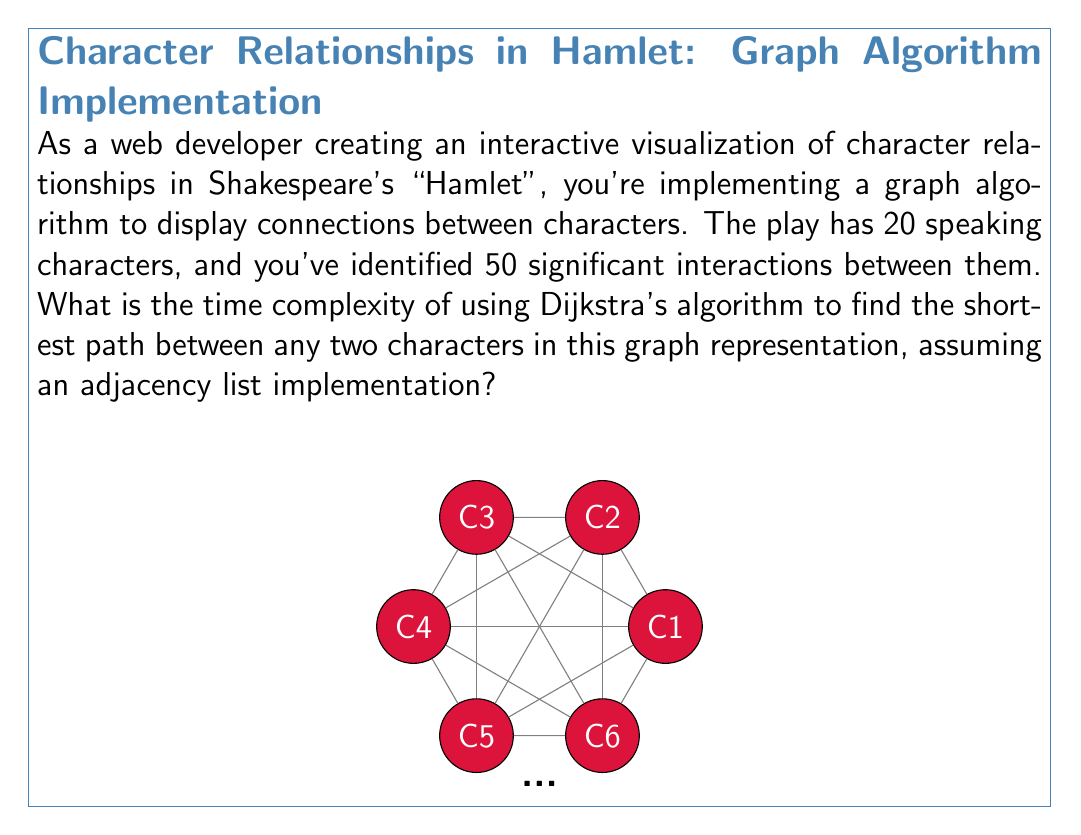Can you solve this math problem? Let's break this down step-by-step:

1) In graph theory, we represent the number of vertices as $V$ and the number of edges as $E$. In this case:
   $V = 20$ (characters)
   $E = 50$ (interactions)

2) Dijkstra's algorithm, when implemented with an adjacency list and a binary heap for the priority queue, has a time complexity of:

   $$O((V + E) \log V)$$

3) This is because:
   - Each vertex is inserted into and extracted from the priority queue once: $O(V \log V)$
   - Each edge is examined once, and may cause an update to the priority queue: $O(E \log V)$

4) Substituting our values:

   $$O((20 + 50) \log 20)$$

5) Simplifying:

   $$O(70 \log 20)$$

6) The $\log 20$ is a constant, so we can simplify further:

   $$O(70) = O(V + E)$$

7) However, in algorithm analysis, we typically express complexity in terms of variables, not specific values. So our final answer should be $O(V + E)$.

This complexity is better than the $O(V^2)$ that would result from using an adjacency matrix implementation, especially for sparse graphs (where $E$ is much less than $V^2$), which is likely the case for character interactions in a play.
Answer: $O(V + E)$ 